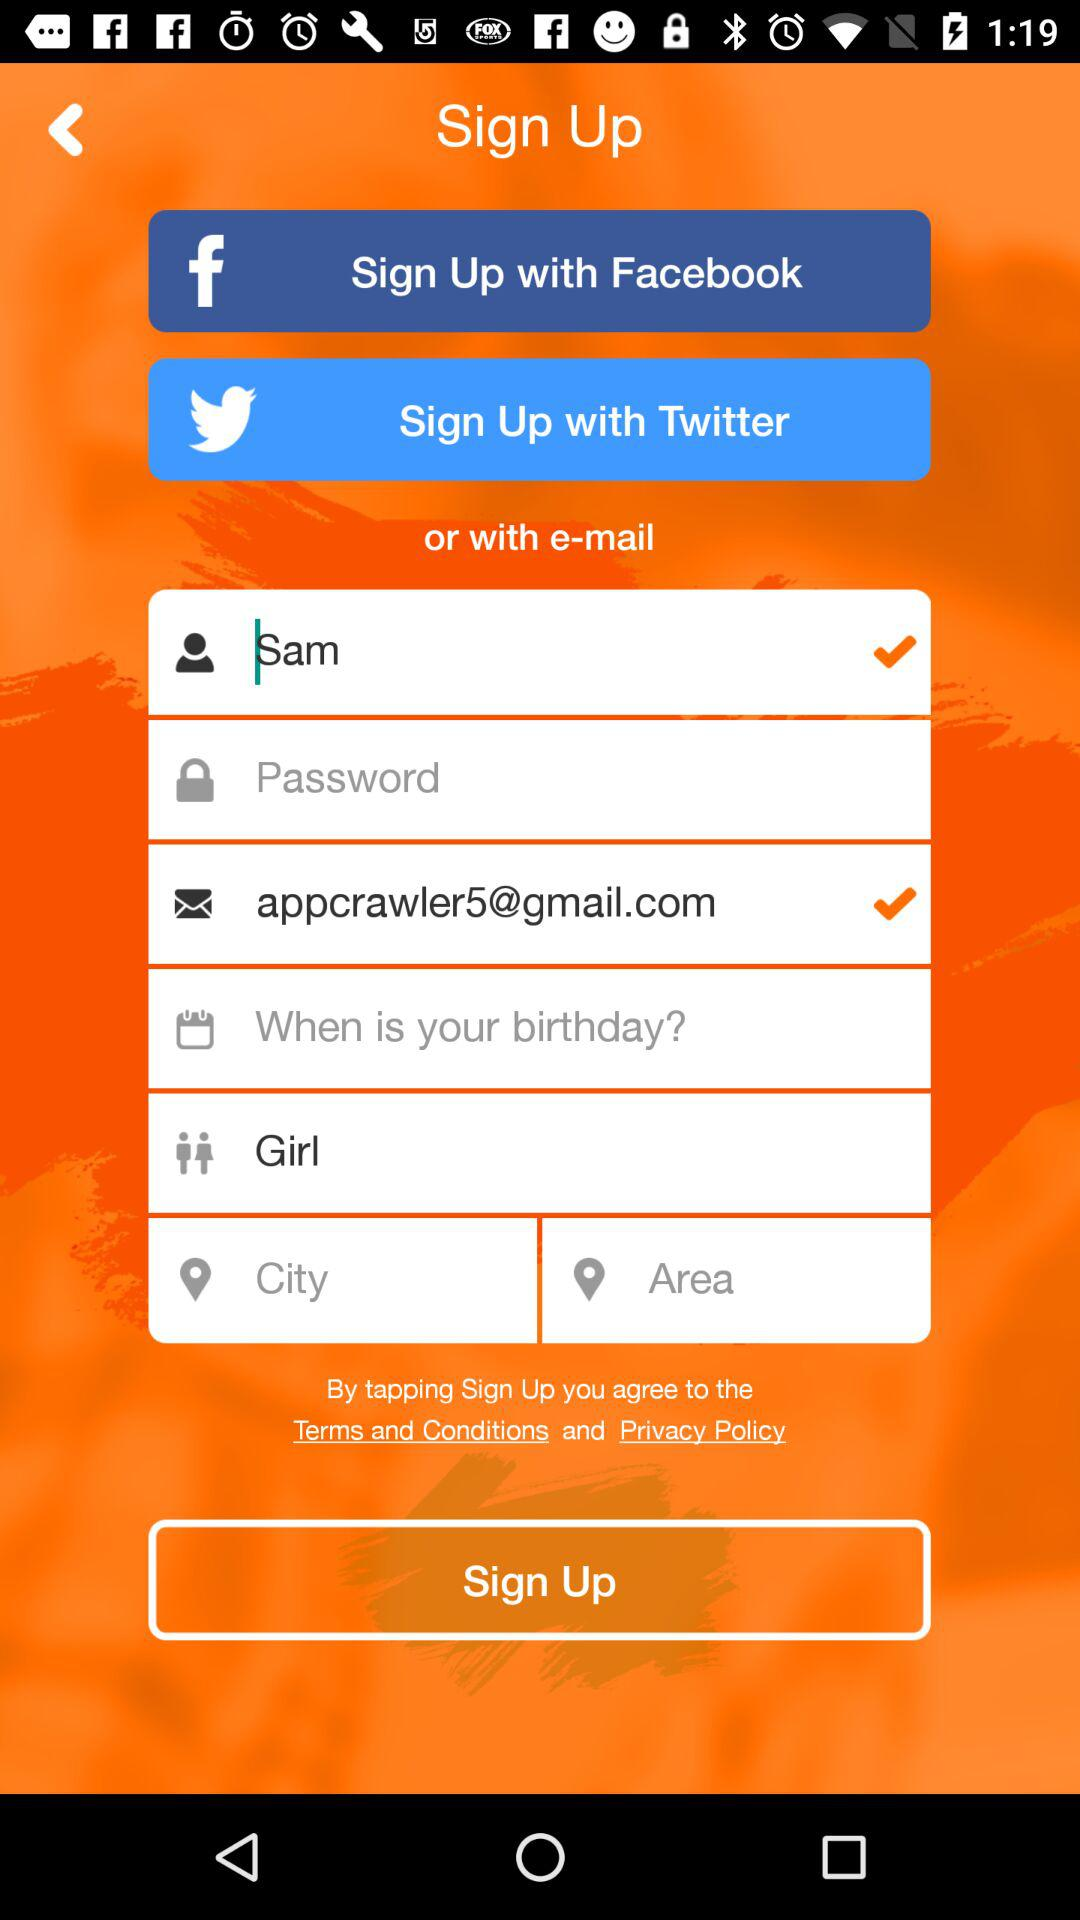What is the first name? The first name is Sam. 